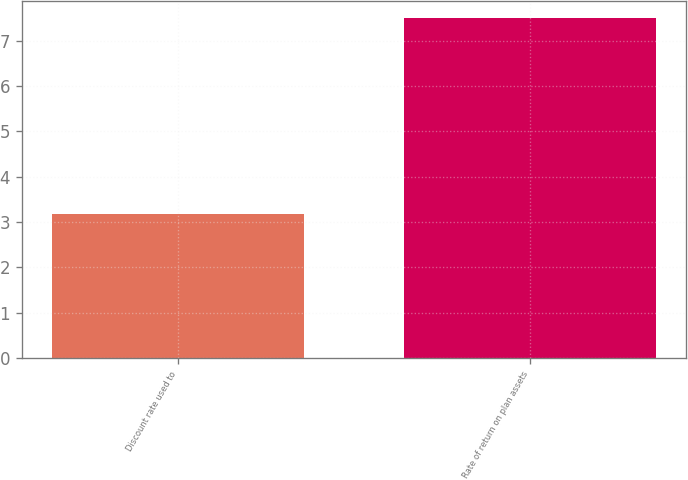<chart> <loc_0><loc_0><loc_500><loc_500><bar_chart><fcel>Discount rate used to<fcel>Rate of return on plan assets<nl><fcel>3.18<fcel>7.5<nl></chart> 